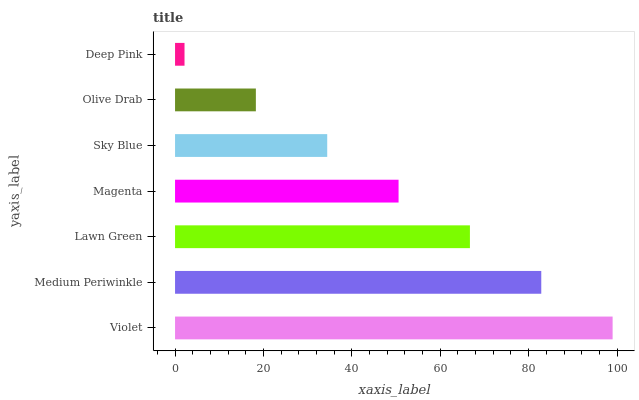Is Deep Pink the minimum?
Answer yes or no. Yes. Is Violet the maximum?
Answer yes or no. Yes. Is Medium Periwinkle the minimum?
Answer yes or no. No. Is Medium Periwinkle the maximum?
Answer yes or no. No. Is Violet greater than Medium Periwinkle?
Answer yes or no. Yes. Is Medium Periwinkle less than Violet?
Answer yes or no. Yes. Is Medium Periwinkle greater than Violet?
Answer yes or no. No. Is Violet less than Medium Periwinkle?
Answer yes or no. No. Is Magenta the high median?
Answer yes or no. Yes. Is Magenta the low median?
Answer yes or no. Yes. Is Violet the high median?
Answer yes or no. No. Is Deep Pink the low median?
Answer yes or no. No. 